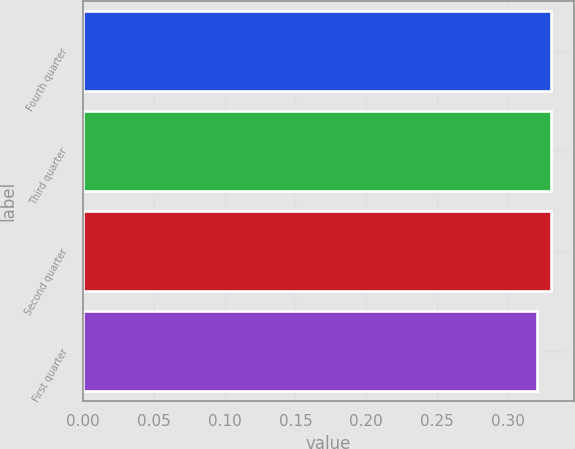<chart> <loc_0><loc_0><loc_500><loc_500><bar_chart><fcel>Fourth quarter<fcel>Third quarter<fcel>Second quarter<fcel>First quarter<nl><fcel>0.33<fcel>0.33<fcel>0.33<fcel>0.32<nl></chart> 